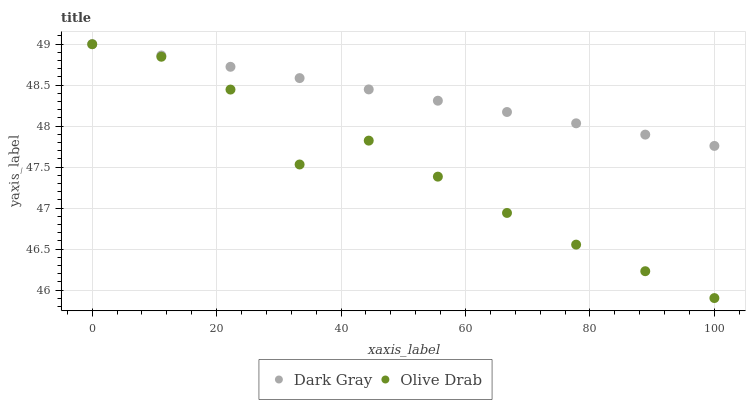Does Olive Drab have the minimum area under the curve?
Answer yes or no. Yes. Does Dark Gray have the maximum area under the curve?
Answer yes or no. Yes. Does Olive Drab have the maximum area under the curve?
Answer yes or no. No. Is Dark Gray the smoothest?
Answer yes or no. Yes. Is Olive Drab the roughest?
Answer yes or no. Yes. Is Olive Drab the smoothest?
Answer yes or no. No. Does Olive Drab have the lowest value?
Answer yes or no. Yes. Does Olive Drab have the highest value?
Answer yes or no. Yes. Does Olive Drab intersect Dark Gray?
Answer yes or no. Yes. Is Olive Drab less than Dark Gray?
Answer yes or no. No. Is Olive Drab greater than Dark Gray?
Answer yes or no. No. 